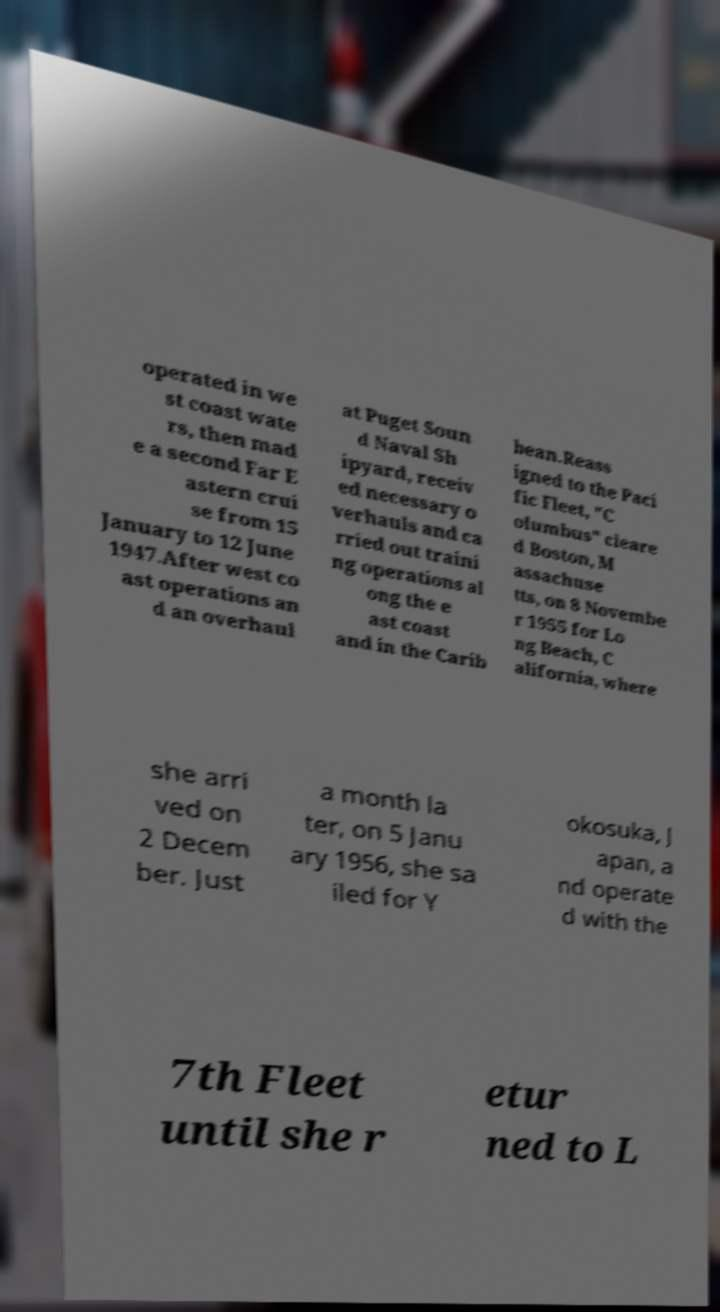Can you read and provide the text displayed in the image?This photo seems to have some interesting text. Can you extract and type it out for me? operated in we st coast wate rs, then mad e a second Far E astern crui se from 15 January to 12 June 1947.After west co ast operations an d an overhaul at Puget Soun d Naval Sh ipyard, receiv ed necessary o verhauls and ca rried out traini ng operations al ong the e ast coast and in the Carib bean.Reass igned to the Paci fic Fleet, "C olumbus" cleare d Boston, M assachuse tts, on 8 Novembe r 1955 for Lo ng Beach, C alifornia, where she arri ved on 2 Decem ber. Just a month la ter, on 5 Janu ary 1956, she sa iled for Y okosuka, J apan, a nd operate d with the 7th Fleet until she r etur ned to L 